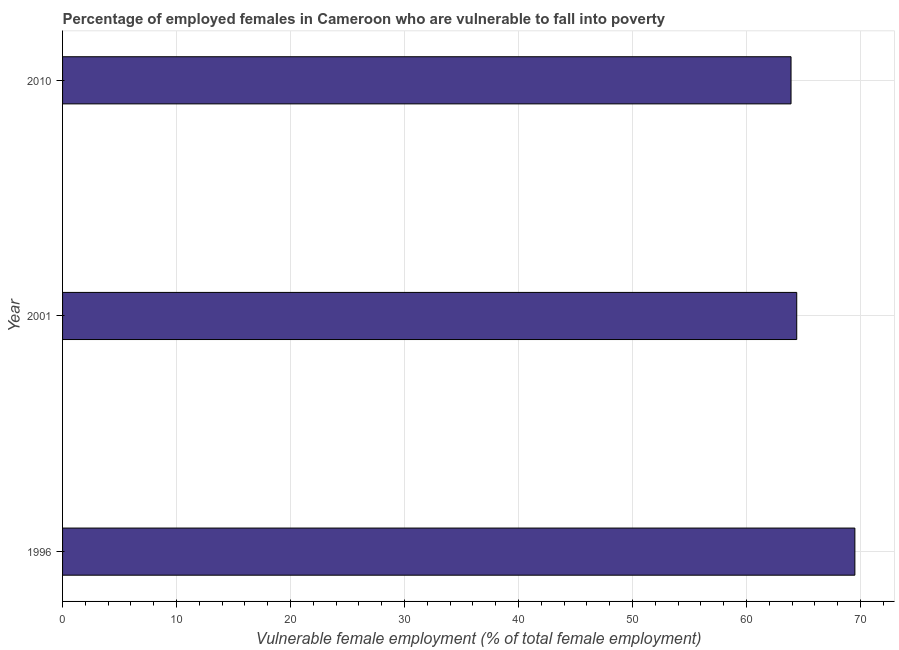Does the graph contain grids?
Ensure brevity in your answer.  Yes. What is the title of the graph?
Your answer should be very brief. Percentage of employed females in Cameroon who are vulnerable to fall into poverty. What is the label or title of the X-axis?
Give a very brief answer. Vulnerable female employment (% of total female employment). What is the label or title of the Y-axis?
Ensure brevity in your answer.  Year. What is the percentage of employed females who are vulnerable to fall into poverty in 1996?
Your answer should be compact. 69.5. Across all years, what is the maximum percentage of employed females who are vulnerable to fall into poverty?
Your answer should be very brief. 69.5. Across all years, what is the minimum percentage of employed females who are vulnerable to fall into poverty?
Offer a very short reply. 63.9. What is the sum of the percentage of employed females who are vulnerable to fall into poverty?
Keep it short and to the point. 197.8. What is the difference between the percentage of employed females who are vulnerable to fall into poverty in 2001 and 2010?
Offer a very short reply. 0.5. What is the average percentage of employed females who are vulnerable to fall into poverty per year?
Make the answer very short. 65.93. What is the median percentage of employed females who are vulnerable to fall into poverty?
Offer a very short reply. 64.4. Do a majority of the years between 2001 and 1996 (inclusive) have percentage of employed females who are vulnerable to fall into poverty greater than 26 %?
Your answer should be very brief. No. What is the ratio of the percentage of employed females who are vulnerable to fall into poverty in 1996 to that in 2010?
Make the answer very short. 1.09. Is the percentage of employed females who are vulnerable to fall into poverty in 2001 less than that in 2010?
Your answer should be very brief. No. Is the sum of the percentage of employed females who are vulnerable to fall into poverty in 2001 and 2010 greater than the maximum percentage of employed females who are vulnerable to fall into poverty across all years?
Your response must be concise. Yes. What is the difference between the highest and the lowest percentage of employed females who are vulnerable to fall into poverty?
Provide a short and direct response. 5.6. In how many years, is the percentage of employed females who are vulnerable to fall into poverty greater than the average percentage of employed females who are vulnerable to fall into poverty taken over all years?
Offer a very short reply. 1. How many bars are there?
Your response must be concise. 3. Are all the bars in the graph horizontal?
Give a very brief answer. Yes. How many years are there in the graph?
Provide a succinct answer. 3. Are the values on the major ticks of X-axis written in scientific E-notation?
Provide a short and direct response. No. What is the Vulnerable female employment (% of total female employment) in 1996?
Your answer should be compact. 69.5. What is the Vulnerable female employment (% of total female employment) in 2001?
Keep it short and to the point. 64.4. What is the Vulnerable female employment (% of total female employment) of 2010?
Offer a very short reply. 63.9. What is the difference between the Vulnerable female employment (% of total female employment) in 1996 and 2001?
Offer a terse response. 5.1. What is the difference between the Vulnerable female employment (% of total female employment) in 1996 and 2010?
Offer a very short reply. 5.6. What is the difference between the Vulnerable female employment (% of total female employment) in 2001 and 2010?
Provide a short and direct response. 0.5. What is the ratio of the Vulnerable female employment (% of total female employment) in 1996 to that in 2001?
Offer a terse response. 1.08. What is the ratio of the Vulnerable female employment (% of total female employment) in 1996 to that in 2010?
Provide a short and direct response. 1.09. What is the ratio of the Vulnerable female employment (% of total female employment) in 2001 to that in 2010?
Offer a terse response. 1.01. 